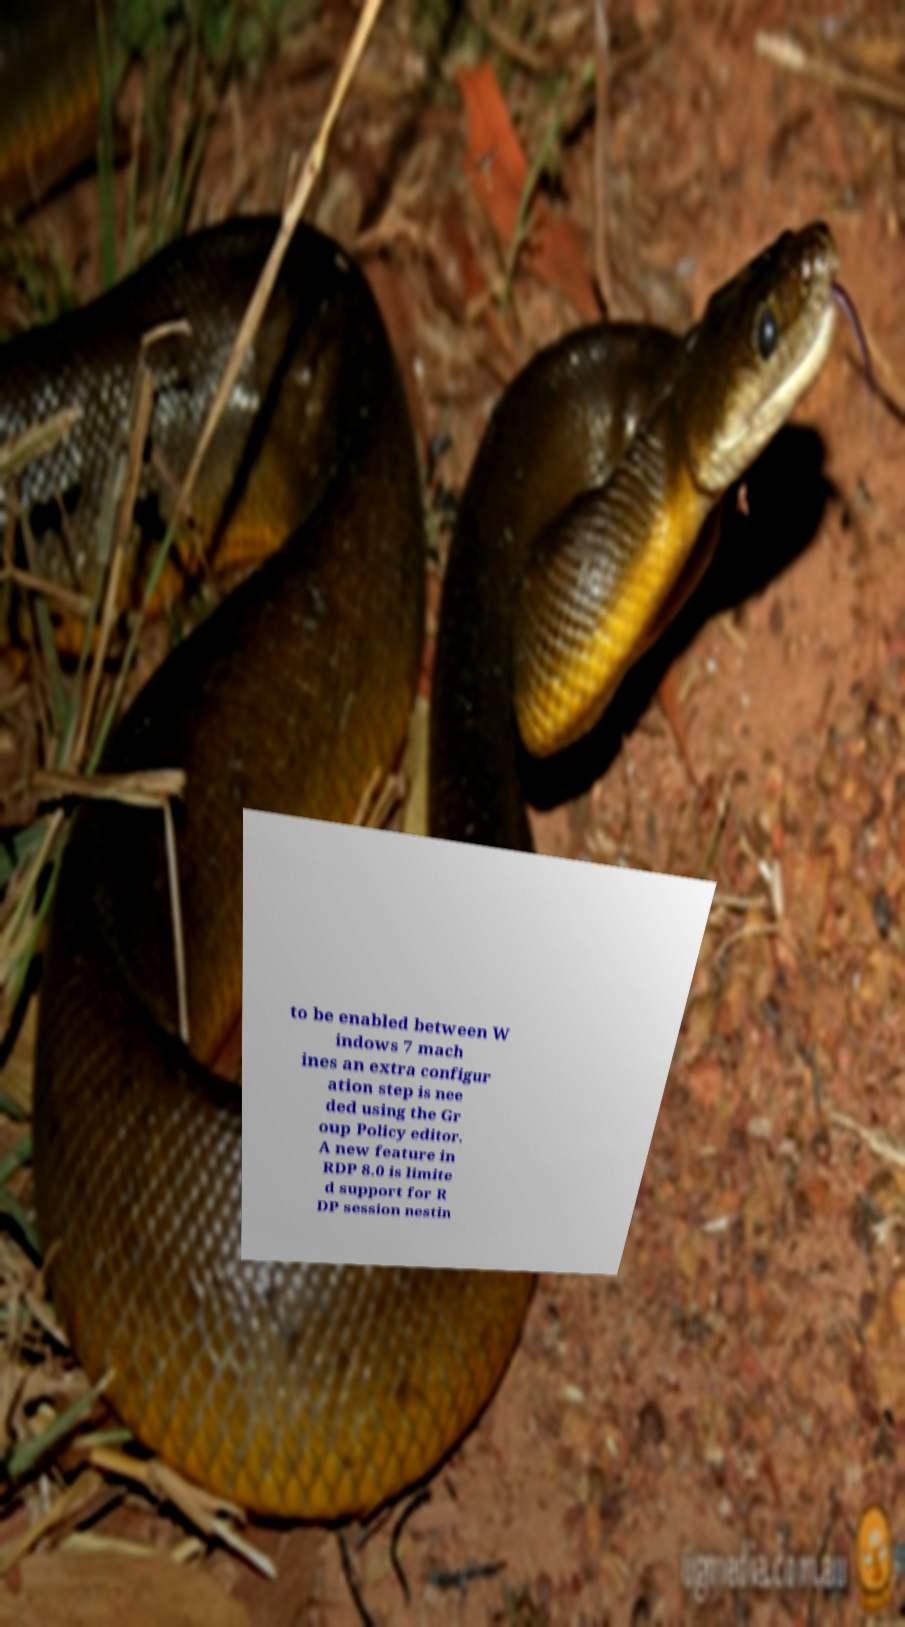Can you accurately transcribe the text from the provided image for me? to be enabled between W indows 7 mach ines an extra configur ation step is nee ded using the Gr oup Policy editor. A new feature in RDP 8.0 is limite d support for R DP session nestin 